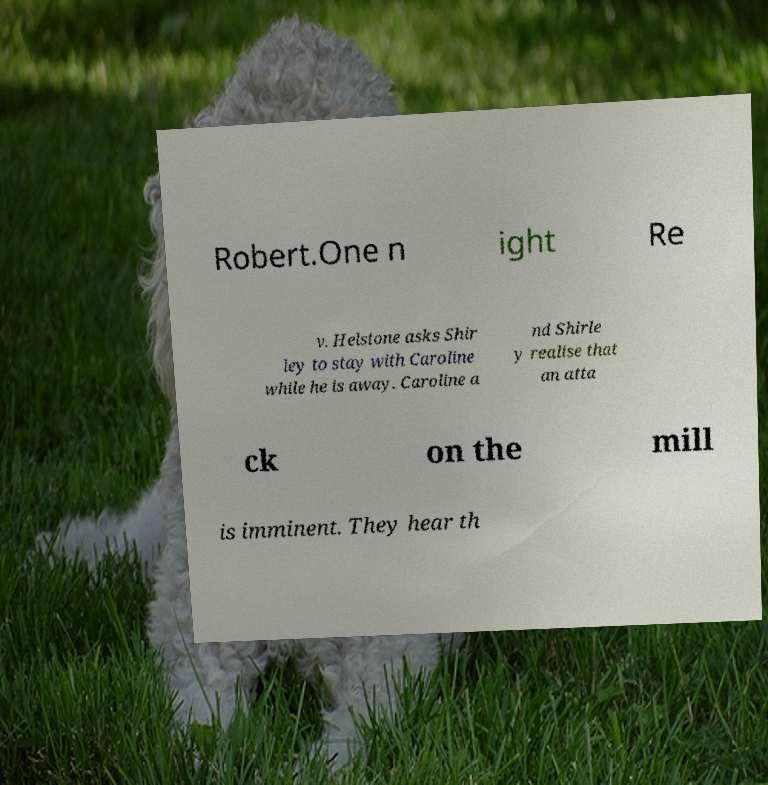Can you accurately transcribe the text from the provided image for me? Robert.One n ight Re v. Helstone asks Shir ley to stay with Caroline while he is away. Caroline a nd Shirle y realise that an atta ck on the mill is imminent. They hear th 